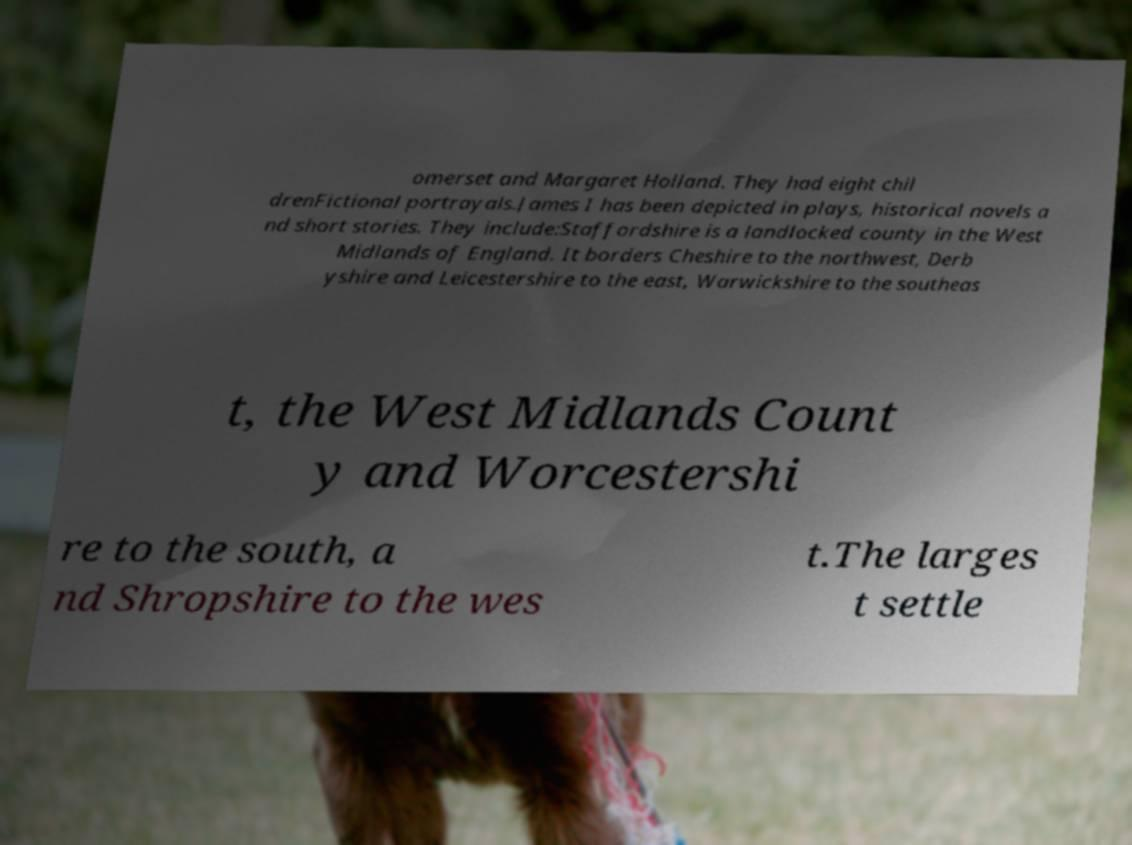There's text embedded in this image that I need extracted. Can you transcribe it verbatim? omerset and Margaret Holland. They had eight chil drenFictional portrayals.James I has been depicted in plays, historical novels a nd short stories. They include:Staffordshire is a landlocked county in the West Midlands of England. It borders Cheshire to the northwest, Derb yshire and Leicestershire to the east, Warwickshire to the southeas t, the West Midlands Count y and Worcestershi re to the south, a nd Shropshire to the wes t.The larges t settle 